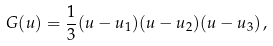Convert formula to latex. <formula><loc_0><loc_0><loc_500><loc_500>G ( u ) = \frac { 1 } { 3 } ( u - u _ { 1 } ) ( u - u _ { 2 } ) ( u - u _ { 3 } ) \, ,</formula> 